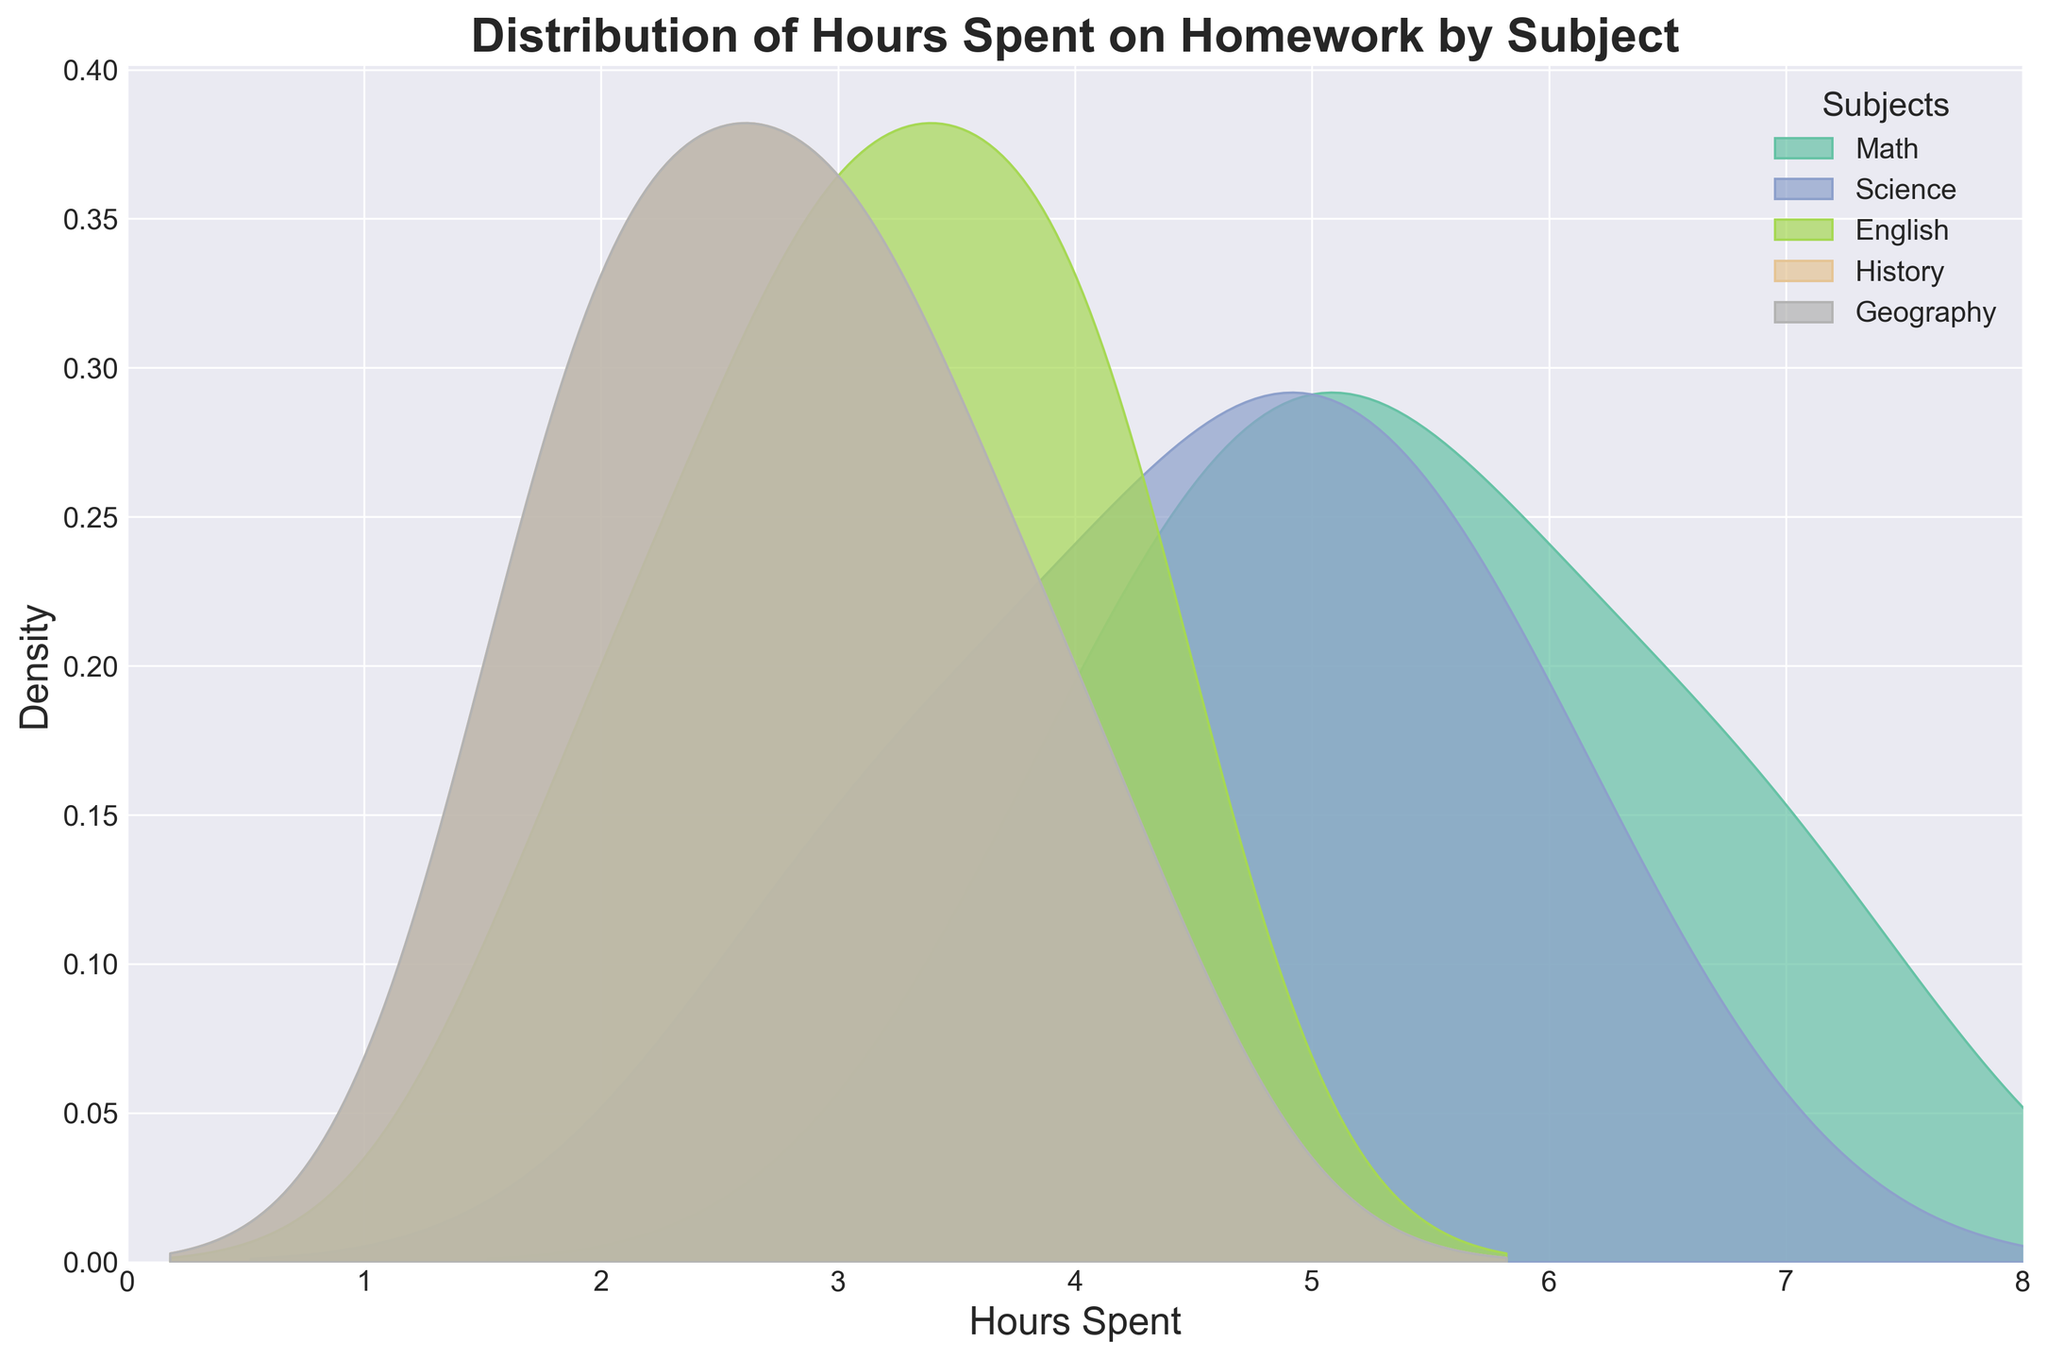Which subject has the highest density peak in the distribution? To determine the highest density peak, look for the subject whose curve reaches the highest point on the y-axis. The peak density for the subject will be the tallest curve.
Answer: Math Which subject has the lowest average hours spent on homework? To determine the average hours spent, observe the central tendency of each subject's density curve. The subject with the peak closest to the left (lower hours) will have the lowest average.
Answer: Geography What is the range of hours spent on homework for the Math subject? The range can be determined by identifying the minimum and maximum points of the distribution curve for Math. Look for the densest beginning and end parts of the curve on the x-axis.
Answer: 4 to 7 Which two subjects have overlapping distribution peaks near the 5-hour mark? Identify the subjects whose curves both have significant density (high peaks) around the 5-hour mark.
Answer: Math and Science How many subjects have their distribution peak between 2 to 4 hours? Count the number of subjects whose peaks are within the 2-4 hour range on the x-axis.
Answer: 4 subjects Compare the density curves for Science and English. Which one has a higher peak? To compare, identify the highest point of the density curves for Science and English. The subject with the higher peak will have the taller curve.
Answer: Science What can you infer about the variability in hours spent for History compared to Math? Higher variability can be inferred from wider and flatter curves, while lower variability is indicated by narrower and steeper curves. Compare the widths and shapes of History and Math's curves.
Answer: History has higher variability Between 3 to 4 hours, which subject shows the highest density of hours spent? Look at the height of the density curves for each subject between 3 to 4 hours on the x-axis. Identify the subject with the tallest curve in this range.
Answer: History Is there any subject whose distribution shows no density at the maximum range of hours spent? If so, which one? Identify if there is any subject density curve that completely drops off before the maximum hour mark on the x-axis.
Answer: English 